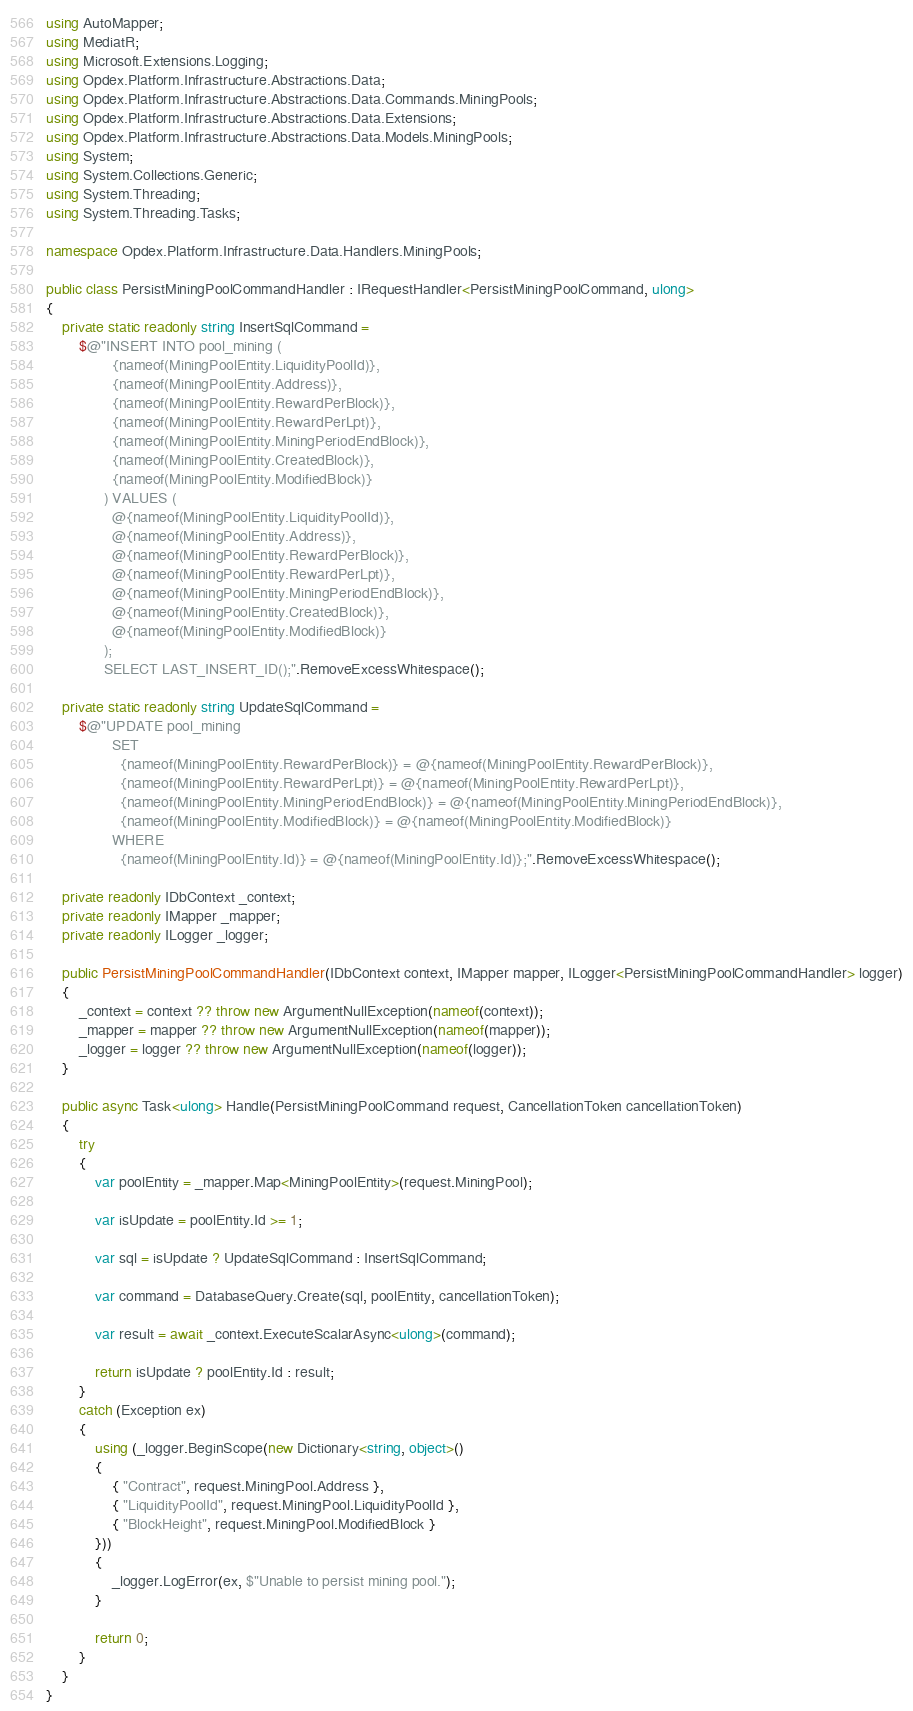<code> <loc_0><loc_0><loc_500><loc_500><_C#_>using AutoMapper;
using MediatR;
using Microsoft.Extensions.Logging;
using Opdex.Platform.Infrastructure.Abstractions.Data;
using Opdex.Platform.Infrastructure.Abstractions.Data.Commands.MiningPools;
using Opdex.Platform.Infrastructure.Abstractions.Data.Extensions;
using Opdex.Platform.Infrastructure.Abstractions.Data.Models.MiningPools;
using System;
using System.Collections.Generic;
using System.Threading;
using System.Threading.Tasks;

namespace Opdex.Platform.Infrastructure.Data.Handlers.MiningPools;

public class PersistMiningPoolCommandHandler : IRequestHandler<PersistMiningPoolCommand, ulong>
{
    private static readonly string InsertSqlCommand =
        $@"INSERT INTO pool_mining (
                {nameof(MiningPoolEntity.LiquidityPoolId)},
                {nameof(MiningPoolEntity.Address)},
                {nameof(MiningPoolEntity.RewardPerBlock)},
                {nameof(MiningPoolEntity.RewardPerLpt)},
                {nameof(MiningPoolEntity.MiningPeriodEndBlock)},
                {nameof(MiningPoolEntity.CreatedBlock)},
                {nameof(MiningPoolEntity.ModifiedBlock)}
              ) VALUES (
                @{nameof(MiningPoolEntity.LiquidityPoolId)},
                @{nameof(MiningPoolEntity.Address)},
                @{nameof(MiningPoolEntity.RewardPerBlock)},
                @{nameof(MiningPoolEntity.RewardPerLpt)},
                @{nameof(MiningPoolEntity.MiningPeriodEndBlock)},
                @{nameof(MiningPoolEntity.CreatedBlock)},
                @{nameof(MiningPoolEntity.ModifiedBlock)}
              );
              SELECT LAST_INSERT_ID();".RemoveExcessWhitespace();

    private static readonly string UpdateSqlCommand =
        $@"UPDATE pool_mining
                SET
                  {nameof(MiningPoolEntity.RewardPerBlock)} = @{nameof(MiningPoolEntity.RewardPerBlock)},
                  {nameof(MiningPoolEntity.RewardPerLpt)} = @{nameof(MiningPoolEntity.RewardPerLpt)},
                  {nameof(MiningPoolEntity.MiningPeriodEndBlock)} = @{nameof(MiningPoolEntity.MiningPeriodEndBlock)},
                  {nameof(MiningPoolEntity.ModifiedBlock)} = @{nameof(MiningPoolEntity.ModifiedBlock)}
                WHERE
                  {nameof(MiningPoolEntity.Id)} = @{nameof(MiningPoolEntity.Id)};".RemoveExcessWhitespace();

    private readonly IDbContext _context;
    private readonly IMapper _mapper;
    private readonly ILogger _logger;

    public PersistMiningPoolCommandHandler(IDbContext context, IMapper mapper, ILogger<PersistMiningPoolCommandHandler> logger)
    {
        _context = context ?? throw new ArgumentNullException(nameof(context));
        _mapper = mapper ?? throw new ArgumentNullException(nameof(mapper));
        _logger = logger ?? throw new ArgumentNullException(nameof(logger));
    }

    public async Task<ulong> Handle(PersistMiningPoolCommand request, CancellationToken cancellationToken)
    {
        try
        {
            var poolEntity = _mapper.Map<MiningPoolEntity>(request.MiningPool);

            var isUpdate = poolEntity.Id >= 1;

            var sql = isUpdate ? UpdateSqlCommand : InsertSqlCommand;

            var command = DatabaseQuery.Create(sql, poolEntity, cancellationToken);

            var result = await _context.ExecuteScalarAsync<ulong>(command);

            return isUpdate ? poolEntity.Id : result;
        }
        catch (Exception ex)
        {
            using (_logger.BeginScope(new Dictionary<string, object>()
            {
                { "Contract", request.MiningPool.Address },
                { "LiquidityPoolId", request.MiningPool.LiquidityPoolId },
                { "BlockHeight", request.MiningPool.ModifiedBlock }
            }))
            {
                _logger.LogError(ex, $"Unable to persist mining pool.");
            }

            return 0;
        }
    }
}</code> 